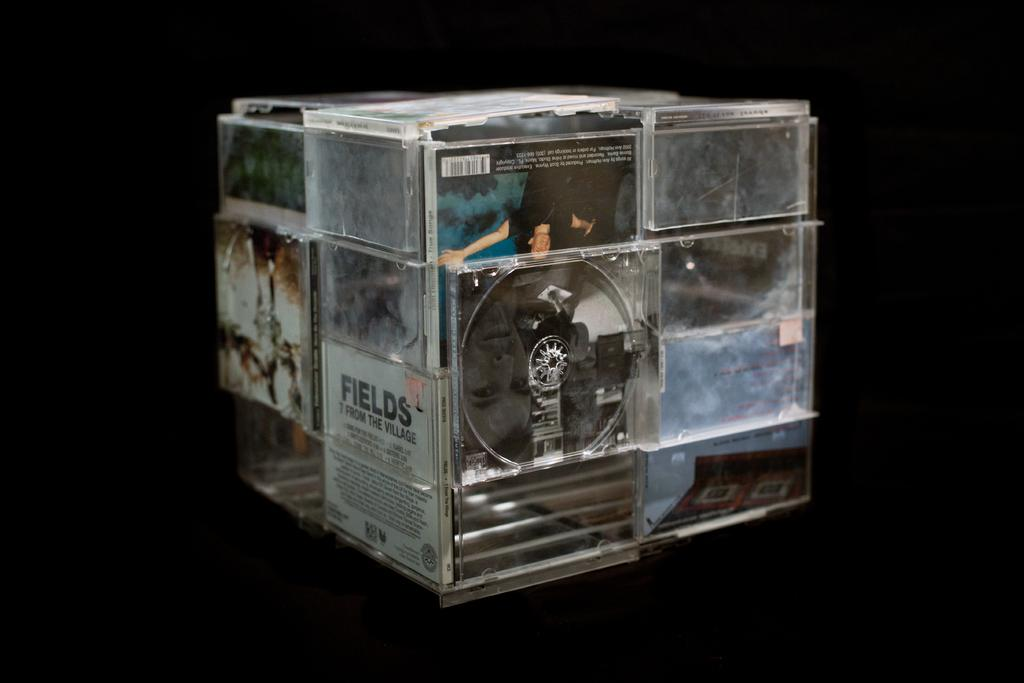Provide a one-sentence caption for the provided image. A cube made of old CD cases including one from Fields. 